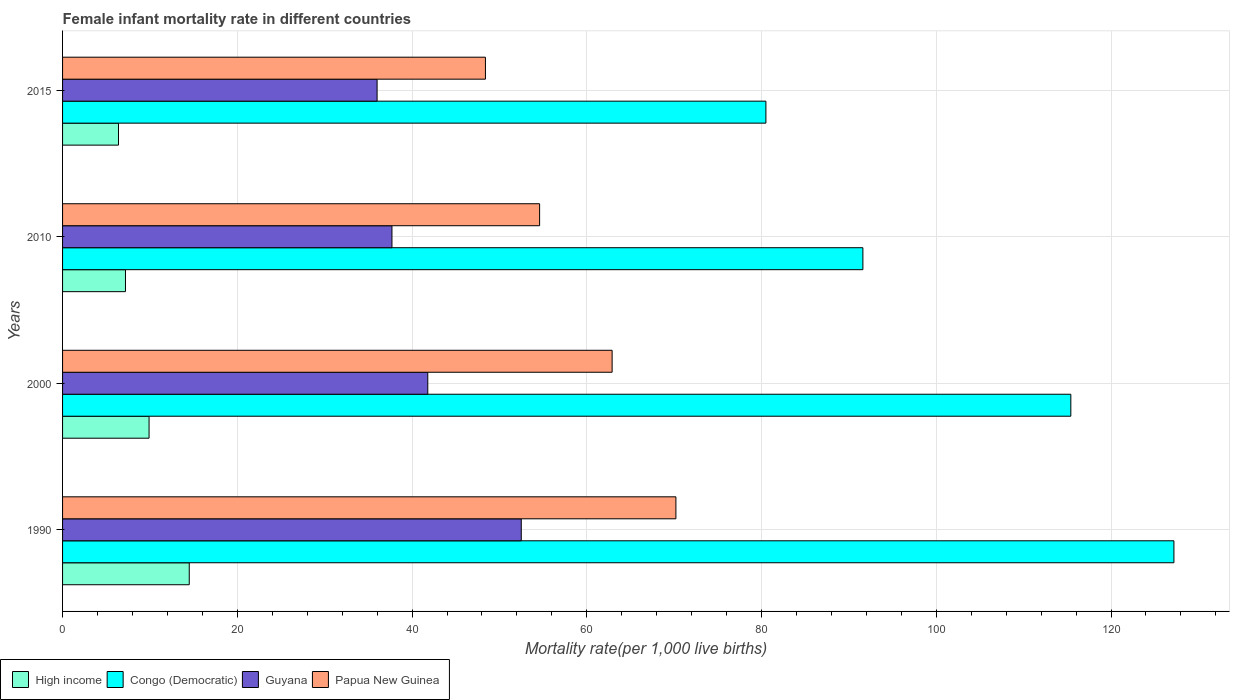How many different coloured bars are there?
Your response must be concise. 4. How many groups of bars are there?
Make the answer very short. 4. Are the number of bars per tick equal to the number of legend labels?
Keep it short and to the point. Yes. How many bars are there on the 1st tick from the top?
Keep it short and to the point. 4. How many bars are there on the 2nd tick from the bottom?
Ensure brevity in your answer.  4. What is the female infant mortality rate in Congo (Democratic) in 2000?
Give a very brief answer. 115.4. Across all years, what is the maximum female infant mortality rate in Papua New Guinea?
Offer a terse response. 70.2. Across all years, what is the minimum female infant mortality rate in Congo (Democratic)?
Your answer should be compact. 80.5. In which year was the female infant mortality rate in Congo (Democratic) maximum?
Give a very brief answer. 1990. In which year was the female infant mortality rate in Guyana minimum?
Offer a very short reply. 2015. What is the total female infant mortality rate in Papua New Guinea in the graph?
Make the answer very short. 236.1. What is the difference between the female infant mortality rate in Papua New Guinea in 1990 and that in 2010?
Keep it short and to the point. 15.6. What is the difference between the female infant mortality rate in High income in 2000 and the female infant mortality rate in Congo (Democratic) in 2015?
Provide a short and direct response. -70.6. What is the average female infant mortality rate in Papua New Guinea per year?
Ensure brevity in your answer.  59.02. In the year 2000, what is the difference between the female infant mortality rate in Papua New Guinea and female infant mortality rate in Guyana?
Your response must be concise. 21.1. What is the ratio of the female infant mortality rate in High income in 2010 to that in 2015?
Make the answer very short. 1.12. Is the female infant mortality rate in Papua New Guinea in 2000 less than that in 2015?
Your answer should be compact. No. Is the difference between the female infant mortality rate in Papua New Guinea in 1990 and 2015 greater than the difference between the female infant mortality rate in Guyana in 1990 and 2015?
Your answer should be very brief. Yes. What is the difference between the highest and the second highest female infant mortality rate in Papua New Guinea?
Keep it short and to the point. 7.3. What does the 1st bar from the top in 1990 represents?
Your answer should be very brief. Papua New Guinea. What does the 1st bar from the bottom in 1990 represents?
Make the answer very short. High income. How many bars are there?
Keep it short and to the point. 16. Are all the bars in the graph horizontal?
Give a very brief answer. Yes. How many years are there in the graph?
Your answer should be very brief. 4. What is the difference between two consecutive major ticks on the X-axis?
Ensure brevity in your answer.  20. What is the title of the graph?
Your answer should be very brief. Female infant mortality rate in different countries. What is the label or title of the X-axis?
Ensure brevity in your answer.  Mortality rate(per 1,0 live births). What is the Mortality rate(per 1,000 live births) in High income in 1990?
Your response must be concise. 14.5. What is the Mortality rate(per 1,000 live births) in Congo (Democratic) in 1990?
Your answer should be very brief. 127.2. What is the Mortality rate(per 1,000 live births) of Guyana in 1990?
Your answer should be compact. 52.5. What is the Mortality rate(per 1,000 live births) of Papua New Guinea in 1990?
Give a very brief answer. 70.2. What is the Mortality rate(per 1,000 live births) of High income in 2000?
Make the answer very short. 9.9. What is the Mortality rate(per 1,000 live births) in Congo (Democratic) in 2000?
Your answer should be very brief. 115.4. What is the Mortality rate(per 1,000 live births) in Guyana in 2000?
Your answer should be very brief. 41.8. What is the Mortality rate(per 1,000 live births) in Papua New Guinea in 2000?
Offer a terse response. 62.9. What is the Mortality rate(per 1,000 live births) in High income in 2010?
Your answer should be compact. 7.2. What is the Mortality rate(per 1,000 live births) of Congo (Democratic) in 2010?
Your answer should be very brief. 91.6. What is the Mortality rate(per 1,000 live births) of Guyana in 2010?
Make the answer very short. 37.7. What is the Mortality rate(per 1,000 live births) of Papua New Guinea in 2010?
Offer a very short reply. 54.6. What is the Mortality rate(per 1,000 live births) of Congo (Democratic) in 2015?
Provide a succinct answer. 80.5. What is the Mortality rate(per 1,000 live births) of Papua New Guinea in 2015?
Give a very brief answer. 48.4. Across all years, what is the maximum Mortality rate(per 1,000 live births) in High income?
Provide a succinct answer. 14.5. Across all years, what is the maximum Mortality rate(per 1,000 live births) in Congo (Democratic)?
Offer a terse response. 127.2. Across all years, what is the maximum Mortality rate(per 1,000 live births) in Guyana?
Ensure brevity in your answer.  52.5. Across all years, what is the maximum Mortality rate(per 1,000 live births) in Papua New Guinea?
Offer a very short reply. 70.2. Across all years, what is the minimum Mortality rate(per 1,000 live births) of Congo (Democratic)?
Your answer should be very brief. 80.5. Across all years, what is the minimum Mortality rate(per 1,000 live births) of Guyana?
Provide a succinct answer. 36. Across all years, what is the minimum Mortality rate(per 1,000 live births) of Papua New Guinea?
Your answer should be very brief. 48.4. What is the total Mortality rate(per 1,000 live births) of High income in the graph?
Your answer should be compact. 38. What is the total Mortality rate(per 1,000 live births) of Congo (Democratic) in the graph?
Provide a succinct answer. 414.7. What is the total Mortality rate(per 1,000 live births) in Guyana in the graph?
Your answer should be compact. 168. What is the total Mortality rate(per 1,000 live births) in Papua New Guinea in the graph?
Offer a very short reply. 236.1. What is the difference between the Mortality rate(per 1,000 live births) in High income in 1990 and that in 2000?
Provide a succinct answer. 4.6. What is the difference between the Mortality rate(per 1,000 live births) of Guyana in 1990 and that in 2000?
Offer a terse response. 10.7. What is the difference between the Mortality rate(per 1,000 live births) of High income in 1990 and that in 2010?
Provide a succinct answer. 7.3. What is the difference between the Mortality rate(per 1,000 live births) in Congo (Democratic) in 1990 and that in 2010?
Your response must be concise. 35.6. What is the difference between the Mortality rate(per 1,000 live births) in Guyana in 1990 and that in 2010?
Your response must be concise. 14.8. What is the difference between the Mortality rate(per 1,000 live births) in Congo (Democratic) in 1990 and that in 2015?
Give a very brief answer. 46.7. What is the difference between the Mortality rate(per 1,000 live births) of Papua New Guinea in 1990 and that in 2015?
Keep it short and to the point. 21.8. What is the difference between the Mortality rate(per 1,000 live births) of High income in 2000 and that in 2010?
Your answer should be very brief. 2.7. What is the difference between the Mortality rate(per 1,000 live births) of Congo (Democratic) in 2000 and that in 2010?
Offer a terse response. 23.8. What is the difference between the Mortality rate(per 1,000 live births) of Guyana in 2000 and that in 2010?
Keep it short and to the point. 4.1. What is the difference between the Mortality rate(per 1,000 live births) of Papua New Guinea in 2000 and that in 2010?
Make the answer very short. 8.3. What is the difference between the Mortality rate(per 1,000 live births) in Congo (Democratic) in 2000 and that in 2015?
Offer a terse response. 34.9. What is the difference between the Mortality rate(per 1,000 live births) of Guyana in 2000 and that in 2015?
Give a very brief answer. 5.8. What is the difference between the Mortality rate(per 1,000 live births) in Congo (Democratic) in 2010 and that in 2015?
Ensure brevity in your answer.  11.1. What is the difference between the Mortality rate(per 1,000 live births) in Guyana in 2010 and that in 2015?
Ensure brevity in your answer.  1.7. What is the difference between the Mortality rate(per 1,000 live births) in High income in 1990 and the Mortality rate(per 1,000 live births) in Congo (Democratic) in 2000?
Your answer should be compact. -100.9. What is the difference between the Mortality rate(per 1,000 live births) in High income in 1990 and the Mortality rate(per 1,000 live births) in Guyana in 2000?
Offer a terse response. -27.3. What is the difference between the Mortality rate(per 1,000 live births) of High income in 1990 and the Mortality rate(per 1,000 live births) of Papua New Guinea in 2000?
Your answer should be compact. -48.4. What is the difference between the Mortality rate(per 1,000 live births) of Congo (Democratic) in 1990 and the Mortality rate(per 1,000 live births) of Guyana in 2000?
Provide a short and direct response. 85.4. What is the difference between the Mortality rate(per 1,000 live births) in Congo (Democratic) in 1990 and the Mortality rate(per 1,000 live births) in Papua New Guinea in 2000?
Keep it short and to the point. 64.3. What is the difference between the Mortality rate(per 1,000 live births) in Guyana in 1990 and the Mortality rate(per 1,000 live births) in Papua New Guinea in 2000?
Your answer should be very brief. -10.4. What is the difference between the Mortality rate(per 1,000 live births) in High income in 1990 and the Mortality rate(per 1,000 live births) in Congo (Democratic) in 2010?
Your response must be concise. -77.1. What is the difference between the Mortality rate(per 1,000 live births) of High income in 1990 and the Mortality rate(per 1,000 live births) of Guyana in 2010?
Offer a terse response. -23.2. What is the difference between the Mortality rate(per 1,000 live births) in High income in 1990 and the Mortality rate(per 1,000 live births) in Papua New Guinea in 2010?
Provide a short and direct response. -40.1. What is the difference between the Mortality rate(per 1,000 live births) in Congo (Democratic) in 1990 and the Mortality rate(per 1,000 live births) in Guyana in 2010?
Your answer should be very brief. 89.5. What is the difference between the Mortality rate(per 1,000 live births) in Congo (Democratic) in 1990 and the Mortality rate(per 1,000 live births) in Papua New Guinea in 2010?
Give a very brief answer. 72.6. What is the difference between the Mortality rate(per 1,000 live births) of Guyana in 1990 and the Mortality rate(per 1,000 live births) of Papua New Guinea in 2010?
Provide a succinct answer. -2.1. What is the difference between the Mortality rate(per 1,000 live births) of High income in 1990 and the Mortality rate(per 1,000 live births) of Congo (Democratic) in 2015?
Provide a succinct answer. -66. What is the difference between the Mortality rate(per 1,000 live births) of High income in 1990 and the Mortality rate(per 1,000 live births) of Guyana in 2015?
Your answer should be compact. -21.5. What is the difference between the Mortality rate(per 1,000 live births) of High income in 1990 and the Mortality rate(per 1,000 live births) of Papua New Guinea in 2015?
Keep it short and to the point. -33.9. What is the difference between the Mortality rate(per 1,000 live births) of Congo (Democratic) in 1990 and the Mortality rate(per 1,000 live births) of Guyana in 2015?
Provide a short and direct response. 91.2. What is the difference between the Mortality rate(per 1,000 live births) in Congo (Democratic) in 1990 and the Mortality rate(per 1,000 live births) in Papua New Guinea in 2015?
Ensure brevity in your answer.  78.8. What is the difference between the Mortality rate(per 1,000 live births) in Guyana in 1990 and the Mortality rate(per 1,000 live births) in Papua New Guinea in 2015?
Your answer should be compact. 4.1. What is the difference between the Mortality rate(per 1,000 live births) of High income in 2000 and the Mortality rate(per 1,000 live births) of Congo (Democratic) in 2010?
Your answer should be very brief. -81.7. What is the difference between the Mortality rate(per 1,000 live births) in High income in 2000 and the Mortality rate(per 1,000 live births) in Guyana in 2010?
Make the answer very short. -27.8. What is the difference between the Mortality rate(per 1,000 live births) in High income in 2000 and the Mortality rate(per 1,000 live births) in Papua New Guinea in 2010?
Your answer should be very brief. -44.7. What is the difference between the Mortality rate(per 1,000 live births) of Congo (Democratic) in 2000 and the Mortality rate(per 1,000 live births) of Guyana in 2010?
Provide a succinct answer. 77.7. What is the difference between the Mortality rate(per 1,000 live births) of Congo (Democratic) in 2000 and the Mortality rate(per 1,000 live births) of Papua New Guinea in 2010?
Provide a succinct answer. 60.8. What is the difference between the Mortality rate(per 1,000 live births) in High income in 2000 and the Mortality rate(per 1,000 live births) in Congo (Democratic) in 2015?
Your response must be concise. -70.6. What is the difference between the Mortality rate(per 1,000 live births) of High income in 2000 and the Mortality rate(per 1,000 live births) of Guyana in 2015?
Provide a succinct answer. -26.1. What is the difference between the Mortality rate(per 1,000 live births) of High income in 2000 and the Mortality rate(per 1,000 live births) of Papua New Guinea in 2015?
Ensure brevity in your answer.  -38.5. What is the difference between the Mortality rate(per 1,000 live births) of Congo (Democratic) in 2000 and the Mortality rate(per 1,000 live births) of Guyana in 2015?
Your answer should be compact. 79.4. What is the difference between the Mortality rate(per 1,000 live births) in Congo (Democratic) in 2000 and the Mortality rate(per 1,000 live births) in Papua New Guinea in 2015?
Keep it short and to the point. 67. What is the difference between the Mortality rate(per 1,000 live births) of Guyana in 2000 and the Mortality rate(per 1,000 live births) of Papua New Guinea in 2015?
Your answer should be compact. -6.6. What is the difference between the Mortality rate(per 1,000 live births) of High income in 2010 and the Mortality rate(per 1,000 live births) of Congo (Democratic) in 2015?
Provide a short and direct response. -73.3. What is the difference between the Mortality rate(per 1,000 live births) in High income in 2010 and the Mortality rate(per 1,000 live births) in Guyana in 2015?
Keep it short and to the point. -28.8. What is the difference between the Mortality rate(per 1,000 live births) of High income in 2010 and the Mortality rate(per 1,000 live births) of Papua New Guinea in 2015?
Your answer should be very brief. -41.2. What is the difference between the Mortality rate(per 1,000 live births) of Congo (Democratic) in 2010 and the Mortality rate(per 1,000 live births) of Guyana in 2015?
Give a very brief answer. 55.6. What is the difference between the Mortality rate(per 1,000 live births) of Congo (Democratic) in 2010 and the Mortality rate(per 1,000 live births) of Papua New Guinea in 2015?
Your response must be concise. 43.2. What is the difference between the Mortality rate(per 1,000 live births) of Guyana in 2010 and the Mortality rate(per 1,000 live births) of Papua New Guinea in 2015?
Keep it short and to the point. -10.7. What is the average Mortality rate(per 1,000 live births) in Congo (Democratic) per year?
Provide a succinct answer. 103.67. What is the average Mortality rate(per 1,000 live births) in Papua New Guinea per year?
Your answer should be compact. 59.02. In the year 1990, what is the difference between the Mortality rate(per 1,000 live births) of High income and Mortality rate(per 1,000 live births) of Congo (Democratic)?
Provide a short and direct response. -112.7. In the year 1990, what is the difference between the Mortality rate(per 1,000 live births) in High income and Mortality rate(per 1,000 live births) in Guyana?
Give a very brief answer. -38. In the year 1990, what is the difference between the Mortality rate(per 1,000 live births) in High income and Mortality rate(per 1,000 live births) in Papua New Guinea?
Offer a terse response. -55.7. In the year 1990, what is the difference between the Mortality rate(per 1,000 live births) in Congo (Democratic) and Mortality rate(per 1,000 live births) in Guyana?
Provide a succinct answer. 74.7. In the year 1990, what is the difference between the Mortality rate(per 1,000 live births) in Congo (Democratic) and Mortality rate(per 1,000 live births) in Papua New Guinea?
Your response must be concise. 57. In the year 1990, what is the difference between the Mortality rate(per 1,000 live births) in Guyana and Mortality rate(per 1,000 live births) in Papua New Guinea?
Ensure brevity in your answer.  -17.7. In the year 2000, what is the difference between the Mortality rate(per 1,000 live births) of High income and Mortality rate(per 1,000 live births) of Congo (Democratic)?
Your response must be concise. -105.5. In the year 2000, what is the difference between the Mortality rate(per 1,000 live births) of High income and Mortality rate(per 1,000 live births) of Guyana?
Provide a short and direct response. -31.9. In the year 2000, what is the difference between the Mortality rate(per 1,000 live births) of High income and Mortality rate(per 1,000 live births) of Papua New Guinea?
Make the answer very short. -53. In the year 2000, what is the difference between the Mortality rate(per 1,000 live births) in Congo (Democratic) and Mortality rate(per 1,000 live births) in Guyana?
Your response must be concise. 73.6. In the year 2000, what is the difference between the Mortality rate(per 1,000 live births) in Congo (Democratic) and Mortality rate(per 1,000 live births) in Papua New Guinea?
Make the answer very short. 52.5. In the year 2000, what is the difference between the Mortality rate(per 1,000 live births) of Guyana and Mortality rate(per 1,000 live births) of Papua New Guinea?
Provide a short and direct response. -21.1. In the year 2010, what is the difference between the Mortality rate(per 1,000 live births) in High income and Mortality rate(per 1,000 live births) in Congo (Democratic)?
Make the answer very short. -84.4. In the year 2010, what is the difference between the Mortality rate(per 1,000 live births) in High income and Mortality rate(per 1,000 live births) in Guyana?
Your answer should be compact. -30.5. In the year 2010, what is the difference between the Mortality rate(per 1,000 live births) in High income and Mortality rate(per 1,000 live births) in Papua New Guinea?
Offer a terse response. -47.4. In the year 2010, what is the difference between the Mortality rate(per 1,000 live births) in Congo (Democratic) and Mortality rate(per 1,000 live births) in Guyana?
Ensure brevity in your answer.  53.9. In the year 2010, what is the difference between the Mortality rate(per 1,000 live births) of Guyana and Mortality rate(per 1,000 live births) of Papua New Guinea?
Provide a short and direct response. -16.9. In the year 2015, what is the difference between the Mortality rate(per 1,000 live births) in High income and Mortality rate(per 1,000 live births) in Congo (Democratic)?
Your answer should be very brief. -74.1. In the year 2015, what is the difference between the Mortality rate(per 1,000 live births) in High income and Mortality rate(per 1,000 live births) in Guyana?
Offer a very short reply. -29.6. In the year 2015, what is the difference between the Mortality rate(per 1,000 live births) in High income and Mortality rate(per 1,000 live births) in Papua New Guinea?
Provide a short and direct response. -42. In the year 2015, what is the difference between the Mortality rate(per 1,000 live births) in Congo (Democratic) and Mortality rate(per 1,000 live births) in Guyana?
Your answer should be very brief. 44.5. In the year 2015, what is the difference between the Mortality rate(per 1,000 live births) in Congo (Democratic) and Mortality rate(per 1,000 live births) in Papua New Guinea?
Provide a succinct answer. 32.1. What is the ratio of the Mortality rate(per 1,000 live births) in High income in 1990 to that in 2000?
Offer a terse response. 1.46. What is the ratio of the Mortality rate(per 1,000 live births) in Congo (Democratic) in 1990 to that in 2000?
Give a very brief answer. 1.1. What is the ratio of the Mortality rate(per 1,000 live births) in Guyana in 1990 to that in 2000?
Offer a very short reply. 1.26. What is the ratio of the Mortality rate(per 1,000 live births) of Papua New Guinea in 1990 to that in 2000?
Ensure brevity in your answer.  1.12. What is the ratio of the Mortality rate(per 1,000 live births) of High income in 1990 to that in 2010?
Provide a succinct answer. 2.01. What is the ratio of the Mortality rate(per 1,000 live births) in Congo (Democratic) in 1990 to that in 2010?
Keep it short and to the point. 1.39. What is the ratio of the Mortality rate(per 1,000 live births) of Guyana in 1990 to that in 2010?
Ensure brevity in your answer.  1.39. What is the ratio of the Mortality rate(per 1,000 live births) of High income in 1990 to that in 2015?
Your response must be concise. 2.27. What is the ratio of the Mortality rate(per 1,000 live births) of Congo (Democratic) in 1990 to that in 2015?
Give a very brief answer. 1.58. What is the ratio of the Mortality rate(per 1,000 live births) in Guyana in 1990 to that in 2015?
Give a very brief answer. 1.46. What is the ratio of the Mortality rate(per 1,000 live births) in Papua New Guinea in 1990 to that in 2015?
Make the answer very short. 1.45. What is the ratio of the Mortality rate(per 1,000 live births) in High income in 2000 to that in 2010?
Offer a very short reply. 1.38. What is the ratio of the Mortality rate(per 1,000 live births) of Congo (Democratic) in 2000 to that in 2010?
Provide a succinct answer. 1.26. What is the ratio of the Mortality rate(per 1,000 live births) of Guyana in 2000 to that in 2010?
Your answer should be very brief. 1.11. What is the ratio of the Mortality rate(per 1,000 live births) of Papua New Guinea in 2000 to that in 2010?
Your answer should be compact. 1.15. What is the ratio of the Mortality rate(per 1,000 live births) in High income in 2000 to that in 2015?
Give a very brief answer. 1.55. What is the ratio of the Mortality rate(per 1,000 live births) in Congo (Democratic) in 2000 to that in 2015?
Your response must be concise. 1.43. What is the ratio of the Mortality rate(per 1,000 live births) in Guyana in 2000 to that in 2015?
Provide a short and direct response. 1.16. What is the ratio of the Mortality rate(per 1,000 live births) in Papua New Guinea in 2000 to that in 2015?
Your response must be concise. 1.3. What is the ratio of the Mortality rate(per 1,000 live births) in Congo (Democratic) in 2010 to that in 2015?
Your answer should be very brief. 1.14. What is the ratio of the Mortality rate(per 1,000 live births) of Guyana in 2010 to that in 2015?
Keep it short and to the point. 1.05. What is the ratio of the Mortality rate(per 1,000 live births) of Papua New Guinea in 2010 to that in 2015?
Make the answer very short. 1.13. What is the difference between the highest and the second highest Mortality rate(per 1,000 live births) of High income?
Offer a very short reply. 4.6. What is the difference between the highest and the second highest Mortality rate(per 1,000 live births) in Congo (Democratic)?
Make the answer very short. 11.8. What is the difference between the highest and the lowest Mortality rate(per 1,000 live births) of High income?
Your answer should be compact. 8.1. What is the difference between the highest and the lowest Mortality rate(per 1,000 live births) of Congo (Democratic)?
Your answer should be compact. 46.7. What is the difference between the highest and the lowest Mortality rate(per 1,000 live births) in Papua New Guinea?
Make the answer very short. 21.8. 